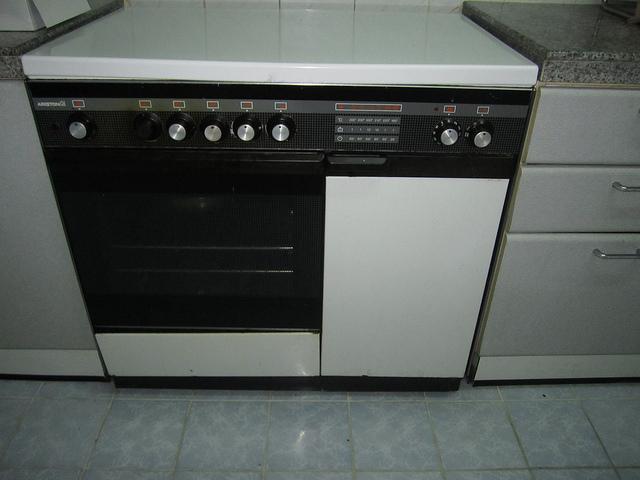How many burners are there in the stove?
Give a very brief answer. 0. 